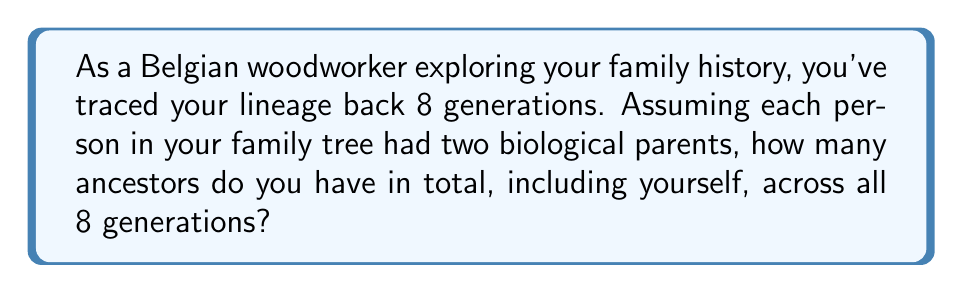Teach me how to tackle this problem. Let's approach this step-by-step:

1) In generation 0 (yourself), there is 1 person.

2) In each subsequent generation, the number of ancestors doubles:
   - Generation 1 (parents): $2^1 = 2$
   - Generation 2 (grandparents): $2^2 = 4$
   - Generation 3 (great-grandparents): $2^3 = 8$
   ...and so on.

3) For generation n, the number of ancestors is $2^n$.

4) To find the total number of ancestors across all generations, we need to sum these numbers from generation 0 to 8:

   $$\sum_{n=0}^8 2^n$$

5) This is a geometric series with first term $a=1$ and common ratio $r=2$.

6) The sum of a geometric series is given by the formula:
   $$S_n = \frac{a(1-r^{n+1})}{1-r}$$
   where $a$ is the first term, $r$ is the common ratio, and $n$ is the number of terms.

7) Plugging in our values ($a=1$, $r=2$, $n=8$):
   $$S_8 = \frac{1(1-2^9)}{1-2} = \frac{1-512}{-1} = 511$$

8) Therefore, the total number of ancestors across all 8 generations, including yourself, is 511.
Answer: 511 